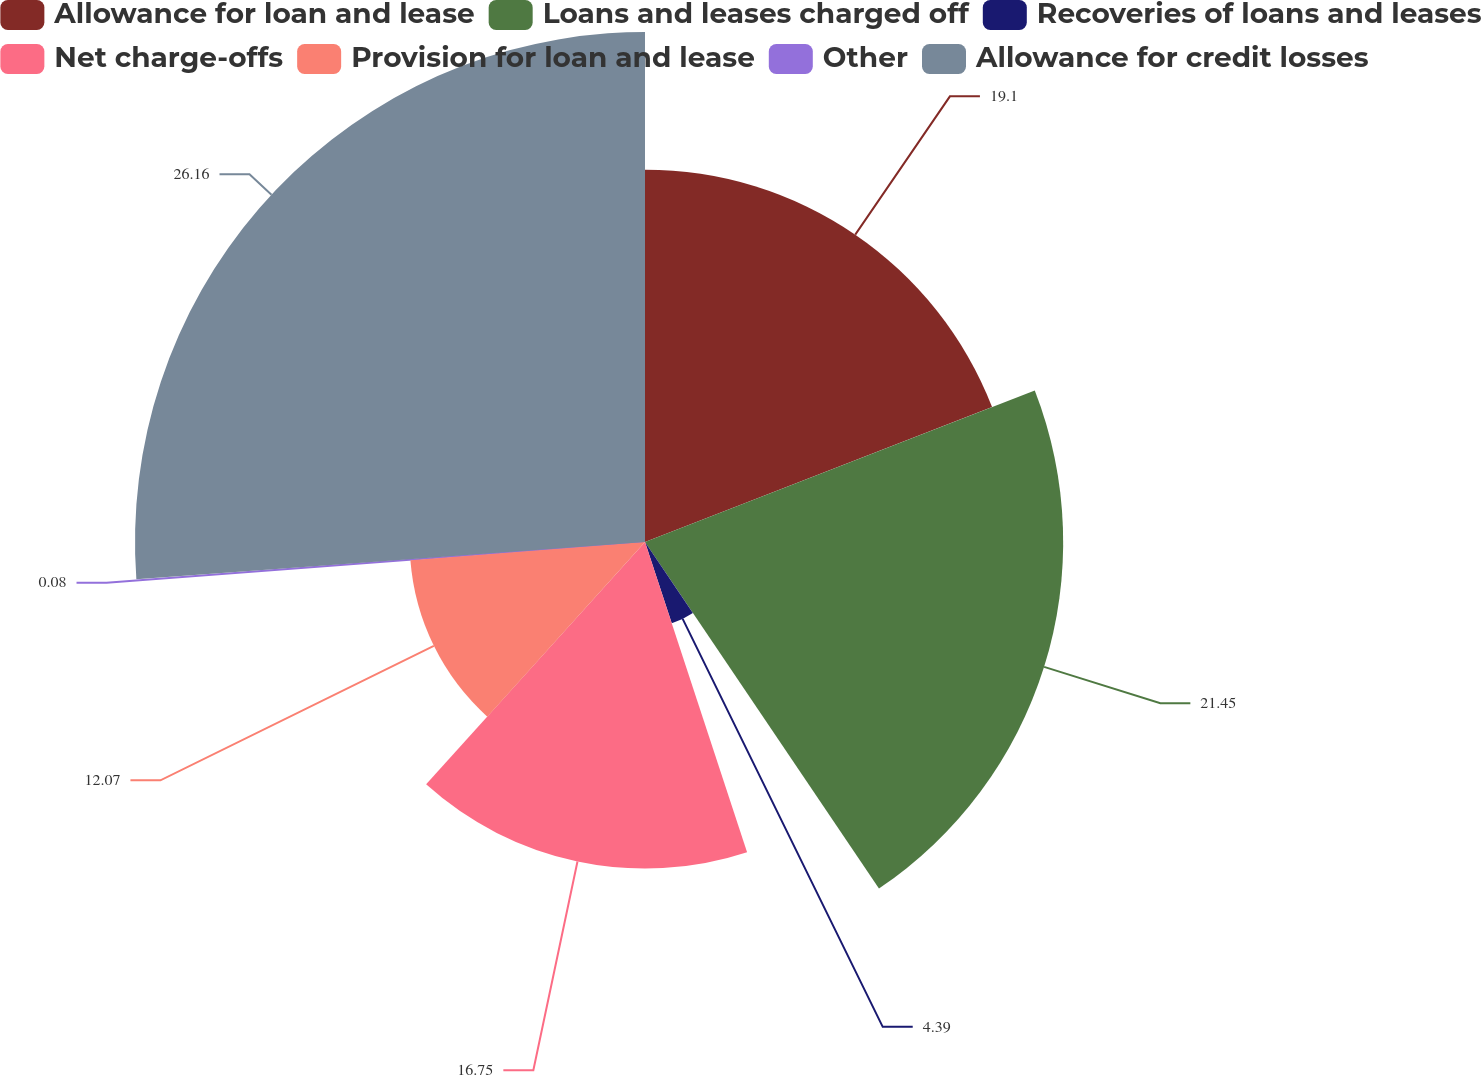Convert chart. <chart><loc_0><loc_0><loc_500><loc_500><pie_chart><fcel>Allowance for loan and lease<fcel>Loans and leases charged off<fcel>Recoveries of loans and leases<fcel>Net charge-offs<fcel>Provision for loan and lease<fcel>Other<fcel>Allowance for credit losses<nl><fcel>19.1%<fcel>21.45%<fcel>4.39%<fcel>16.75%<fcel>12.07%<fcel>0.08%<fcel>26.16%<nl></chart> 